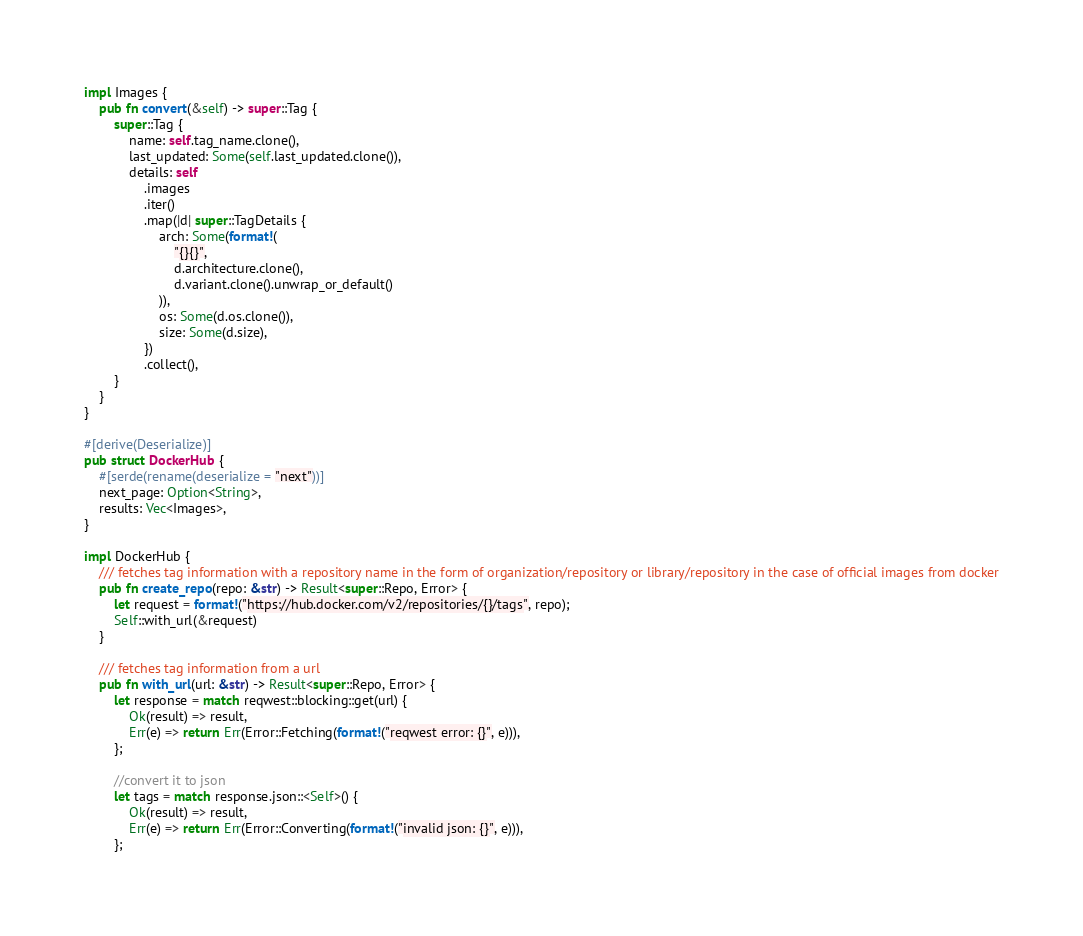Convert code to text. <code><loc_0><loc_0><loc_500><loc_500><_Rust_>impl Images {
    pub fn convert(&self) -> super::Tag {
        super::Tag {
            name: self.tag_name.clone(),
            last_updated: Some(self.last_updated.clone()),
            details: self
                .images
                .iter()
                .map(|d| super::TagDetails {
                    arch: Some(format!(
                        "{}{}",
                        d.architecture.clone(),
                        d.variant.clone().unwrap_or_default()
                    )),
                    os: Some(d.os.clone()),
                    size: Some(d.size),
                })
                .collect(),
        }
    }
}

#[derive(Deserialize)]
pub struct DockerHub {
    #[serde(rename(deserialize = "next"))]
    next_page: Option<String>,
    results: Vec<Images>,
}

impl DockerHub {
    /// fetches tag information with a repository name in the form of organization/repository or library/repository in the case of official images from docker
    pub fn create_repo(repo: &str) -> Result<super::Repo, Error> {
        let request = format!("https://hub.docker.com/v2/repositories/{}/tags", repo);
        Self::with_url(&request)
    }

    /// fetches tag information from a url
    pub fn with_url(url: &str) -> Result<super::Repo, Error> {
        let response = match reqwest::blocking::get(url) {
            Ok(result) => result,
            Err(e) => return Err(Error::Fetching(format!("reqwest error: {}", e))),
        };

        //convert it to json
        let tags = match response.json::<Self>() {
            Ok(result) => result,
            Err(e) => return Err(Error::Converting(format!("invalid json: {}", e))),
        };
</code> 